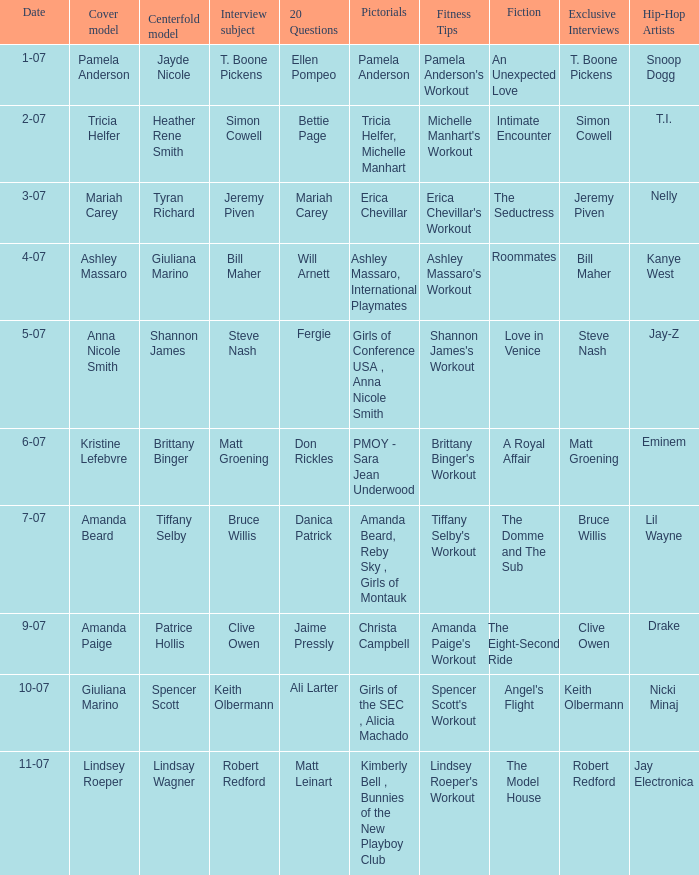Can you parse all the data within this table? {'header': ['Date', 'Cover model', 'Centerfold model', 'Interview subject', '20 Questions', 'Pictorials', 'Fitness Tips', 'Fiction', 'Exclusive Interviews', 'Hip-Hop Artists'], 'rows': [['1-07', 'Pamela Anderson', 'Jayde Nicole', 'T. Boone Pickens', 'Ellen Pompeo', 'Pamela Anderson', "Pamela Anderson's Workout", 'An Unexpected Love', 'T. Boone Pickens', 'Snoop Dogg'], ['2-07', 'Tricia Helfer', 'Heather Rene Smith', 'Simon Cowell', 'Bettie Page', 'Tricia Helfer, Michelle Manhart', "Michelle Manhart's Workout", 'Intimate Encounter', 'Simon Cowell', 'T.I.'], ['3-07', 'Mariah Carey', 'Tyran Richard', 'Jeremy Piven', 'Mariah Carey', 'Erica Chevillar', "Erica Chevillar's Workout", 'The Seductress', 'Jeremy Piven', 'Nelly'], ['4-07', 'Ashley Massaro', 'Giuliana Marino', 'Bill Maher', 'Will Arnett', 'Ashley Massaro, International Playmates', "Ashley Massaro's Workout", 'Roommates', 'Bill Maher', 'Kanye West'], ['5-07', 'Anna Nicole Smith', 'Shannon James', 'Steve Nash', 'Fergie', 'Girls of Conference USA , Anna Nicole Smith', "Shannon James's Workout", 'Love in Venice', 'Steve Nash', 'Jay-Z'], ['6-07', 'Kristine Lefebvre', 'Brittany Binger', 'Matt Groening', 'Don Rickles', 'PMOY - Sara Jean Underwood', "Brittany Binger's Workout", 'A Royal Affair', 'Matt Groening', 'Eminem'], ['7-07', 'Amanda Beard', 'Tiffany Selby', 'Bruce Willis', 'Danica Patrick', 'Amanda Beard, Reby Sky , Girls of Montauk', "Tiffany Selby's Workout", 'The Domme and The Sub', 'Bruce Willis', 'Lil Wayne'], ['9-07', 'Amanda Paige', 'Patrice Hollis', 'Clive Owen', 'Jaime Pressly', 'Christa Campbell', "Amanda Paige's Workout", 'The Eight-Second Ride', 'Clive Owen', 'Drake'], ['10-07', 'Giuliana Marino', 'Spencer Scott', 'Keith Olbermann', 'Ali Larter', 'Girls of the SEC , Alicia Machado', "Spencer Scott's Workout", "Angel's Flight", 'Keith Olbermann', 'Nicki Minaj'], ['11-07', 'Lindsey Roeper', 'Lindsay Wagner', 'Robert Redford', 'Matt Leinart', 'Kimberly Bell , Bunnies of the New Playboy Club', "Lindsey Roeper's Workout", 'The Model House', 'Robert Redford', 'Jay Electronica']]} Who was the centerfold model when the issue's pictorial was kimberly bell , bunnies of the new playboy club? Lindsay Wagner. 